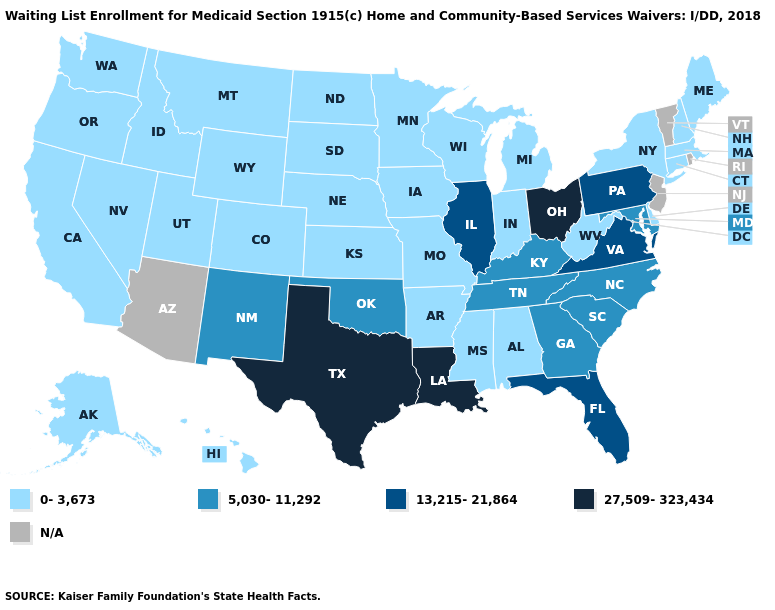Name the states that have a value in the range 5,030-11,292?
Concise answer only. Georgia, Kentucky, Maryland, New Mexico, North Carolina, Oklahoma, South Carolina, Tennessee. How many symbols are there in the legend?
Concise answer only. 5. Does the first symbol in the legend represent the smallest category?
Concise answer only. Yes. What is the highest value in states that border West Virginia?
Concise answer only. 27,509-323,434. What is the value of Connecticut?
Short answer required. 0-3,673. Is the legend a continuous bar?
Short answer required. No. What is the value of New Hampshire?
Answer briefly. 0-3,673. What is the highest value in the USA?
Write a very short answer. 27,509-323,434. Which states have the lowest value in the USA?
Answer briefly. Alabama, Alaska, Arkansas, California, Colorado, Connecticut, Delaware, Hawaii, Idaho, Indiana, Iowa, Kansas, Maine, Massachusetts, Michigan, Minnesota, Mississippi, Missouri, Montana, Nebraska, Nevada, New Hampshire, New York, North Dakota, Oregon, South Dakota, Utah, Washington, West Virginia, Wisconsin, Wyoming. Name the states that have a value in the range N/A?
Be succinct. Arizona, New Jersey, Rhode Island, Vermont. What is the value of Maryland?
Short answer required. 5,030-11,292. What is the value of Utah?
Be succinct. 0-3,673. What is the highest value in states that border Oregon?
Quick response, please. 0-3,673. Name the states that have a value in the range 27,509-323,434?
Give a very brief answer. Louisiana, Ohio, Texas. What is the value of Maryland?
Write a very short answer. 5,030-11,292. 